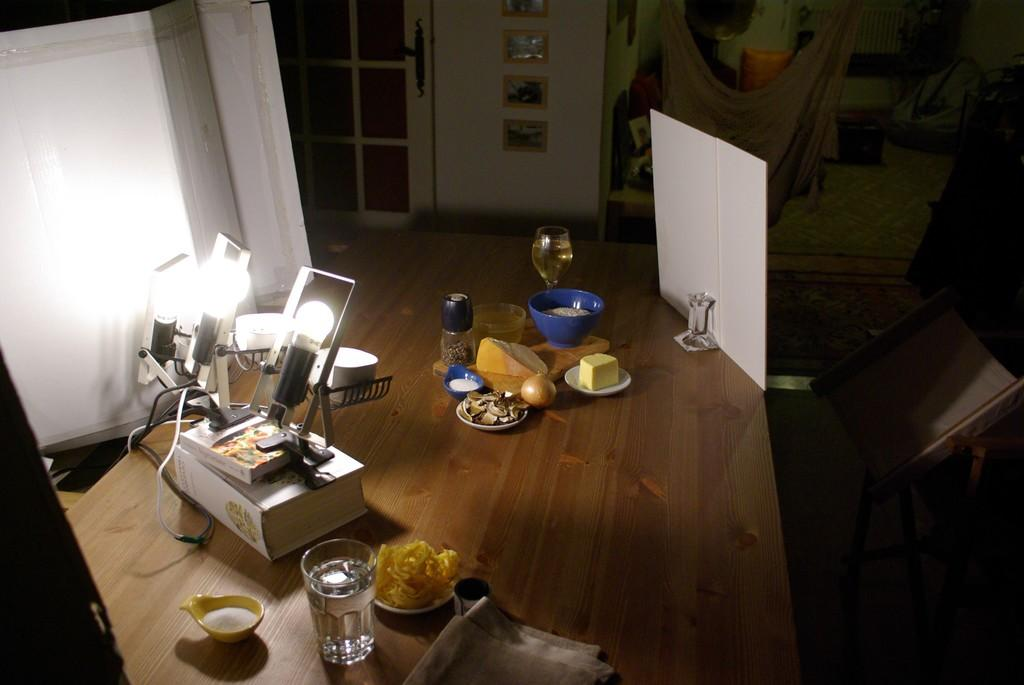What is the main object in the center of the image? There is a table in the center of the image. What can be found on the table? The table contains food items, glasses, and lights. Is there any entrance or exit visible in the image? Yes, there is a door in the image. What is located at the top side of the image? There are portraits at the top side of the image. What invention is being showcased in the image? There is no specific invention being showcased in the image; it primarily features a table with various items on it. What country is depicted in the image? The image does not depict a specific country; it is a general scene featuring a table and other objects. 